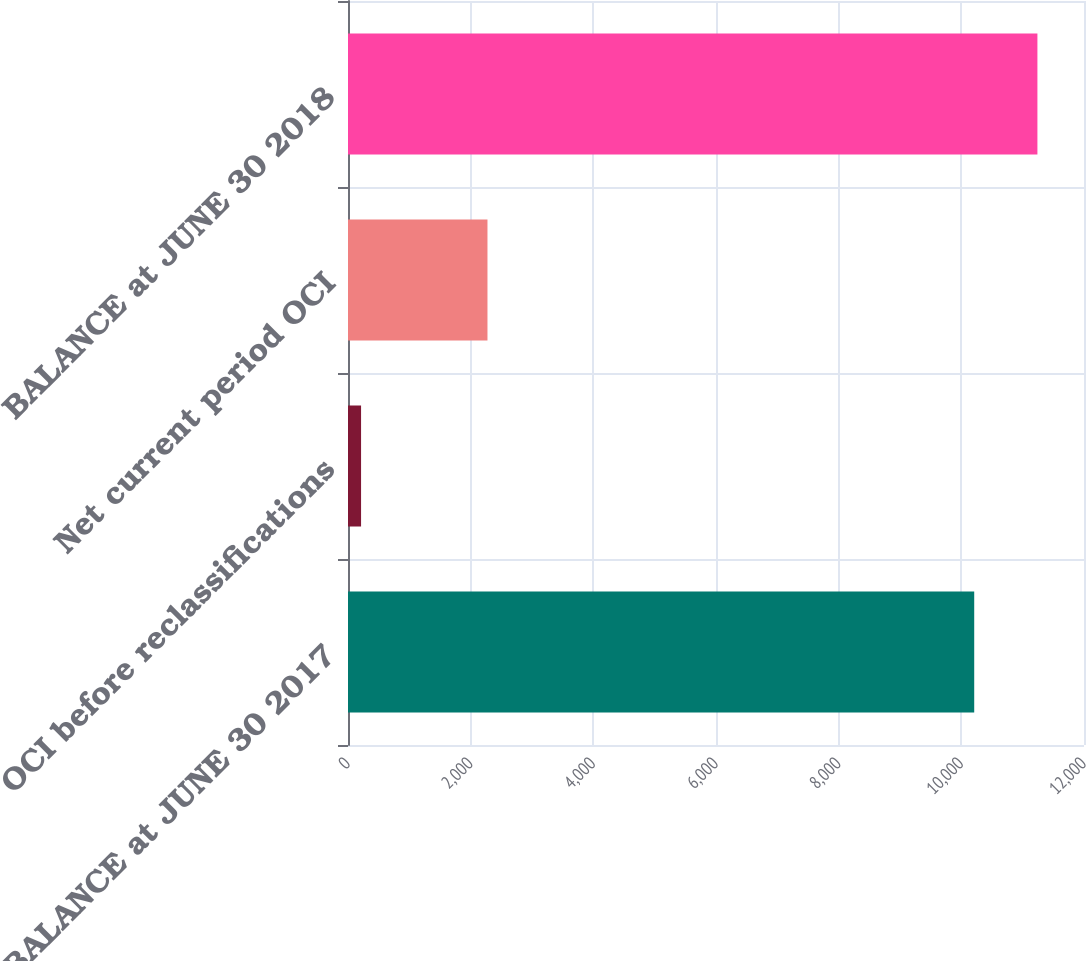Convert chart to OTSL. <chart><loc_0><loc_0><loc_500><loc_500><bar_chart><fcel>BALANCE at JUNE 30 2017<fcel>OCI before reclassifications<fcel>Net current period OCI<fcel>BALANCE at JUNE 30 2018<nl><fcel>10210<fcel>213<fcel>2274<fcel>11240.5<nl></chart> 